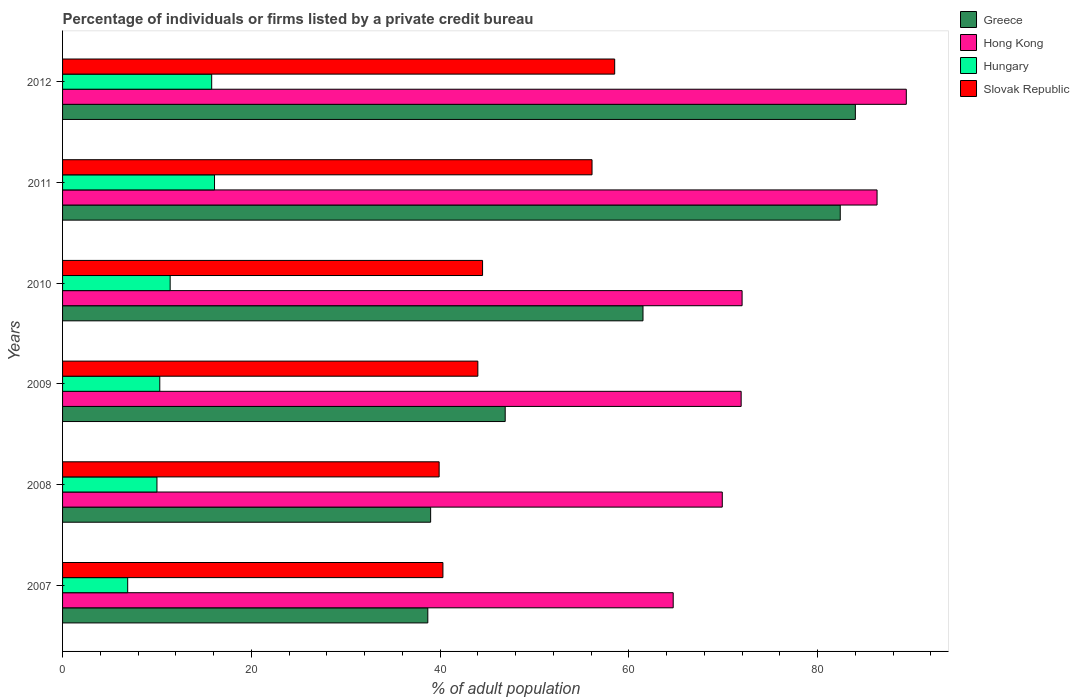How many different coloured bars are there?
Ensure brevity in your answer.  4. Are the number of bars per tick equal to the number of legend labels?
Ensure brevity in your answer.  Yes. Are the number of bars on each tick of the Y-axis equal?
Offer a terse response. Yes. How many bars are there on the 3rd tick from the bottom?
Make the answer very short. 4. Across all years, what is the maximum percentage of population listed by a private credit bureau in Hungary?
Keep it short and to the point. 16.1. Across all years, what is the minimum percentage of population listed by a private credit bureau in Slovak Republic?
Give a very brief answer. 39.9. In which year was the percentage of population listed by a private credit bureau in Greece minimum?
Give a very brief answer. 2007. What is the total percentage of population listed by a private credit bureau in Slovak Republic in the graph?
Ensure brevity in your answer.  283.3. What is the difference between the percentage of population listed by a private credit bureau in Greece in 2010 and that in 2012?
Provide a short and direct response. -22.5. What is the difference between the percentage of population listed by a private credit bureau in Slovak Republic in 2011 and the percentage of population listed by a private credit bureau in Hungary in 2007?
Your response must be concise. 49.2. What is the average percentage of population listed by a private credit bureau in Greece per year?
Keep it short and to the point. 58.75. What is the ratio of the percentage of population listed by a private credit bureau in Hong Kong in 2007 to that in 2012?
Your answer should be very brief. 0.72. Is the percentage of population listed by a private credit bureau in Hong Kong in 2007 less than that in 2012?
Your answer should be very brief. Yes. What is the difference between the highest and the second highest percentage of population listed by a private credit bureau in Slovak Republic?
Give a very brief answer. 2.4. What is the difference between the highest and the lowest percentage of population listed by a private credit bureau in Slovak Republic?
Provide a succinct answer. 18.6. In how many years, is the percentage of population listed by a private credit bureau in Slovak Republic greater than the average percentage of population listed by a private credit bureau in Slovak Republic taken over all years?
Provide a succinct answer. 2. Is the sum of the percentage of population listed by a private credit bureau in Greece in 2011 and 2012 greater than the maximum percentage of population listed by a private credit bureau in Slovak Republic across all years?
Your answer should be very brief. Yes. Is it the case that in every year, the sum of the percentage of population listed by a private credit bureau in Hong Kong and percentage of population listed by a private credit bureau in Slovak Republic is greater than the sum of percentage of population listed by a private credit bureau in Greece and percentage of population listed by a private credit bureau in Hungary?
Provide a succinct answer. Yes. What does the 1st bar from the top in 2011 represents?
Keep it short and to the point. Slovak Republic. Is it the case that in every year, the sum of the percentage of population listed by a private credit bureau in Hong Kong and percentage of population listed by a private credit bureau in Slovak Republic is greater than the percentage of population listed by a private credit bureau in Greece?
Keep it short and to the point. Yes. Are all the bars in the graph horizontal?
Ensure brevity in your answer.  Yes. Are the values on the major ticks of X-axis written in scientific E-notation?
Your answer should be compact. No. Does the graph contain grids?
Give a very brief answer. No. Where does the legend appear in the graph?
Your response must be concise. Top right. What is the title of the graph?
Provide a short and direct response. Percentage of individuals or firms listed by a private credit bureau. What is the label or title of the X-axis?
Ensure brevity in your answer.  % of adult population. What is the % of adult population in Greece in 2007?
Make the answer very short. 38.7. What is the % of adult population of Hong Kong in 2007?
Your response must be concise. 64.7. What is the % of adult population in Slovak Republic in 2007?
Provide a short and direct response. 40.3. What is the % of adult population of Greece in 2008?
Keep it short and to the point. 39. What is the % of adult population of Hong Kong in 2008?
Keep it short and to the point. 69.9. What is the % of adult population of Slovak Republic in 2008?
Ensure brevity in your answer.  39.9. What is the % of adult population of Greece in 2009?
Provide a succinct answer. 46.9. What is the % of adult population in Hong Kong in 2009?
Ensure brevity in your answer.  71.9. What is the % of adult population of Hungary in 2009?
Make the answer very short. 10.3. What is the % of adult population of Slovak Republic in 2009?
Make the answer very short. 44. What is the % of adult population of Greece in 2010?
Keep it short and to the point. 61.5. What is the % of adult population of Hong Kong in 2010?
Provide a short and direct response. 72. What is the % of adult population of Slovak Republic in 2010?
Keep it short and to the point. 44.5. What is the % of adult population of Greece in 2011?
Your answer should be compact. 82.4. What is the % of adult population in Hong Kong in 2011?
Your answer should be compact. 86.3. What is the % of adult population of Hungary in 2011?
Provide a succinct answer. 16.1. What is the % of adult population of Slovak Republic in 2011?
Your answer should be very brief. 56.1. What is the % of adult population of Hong Kong in 2012?
Keep it short and to the point. 89.4. What is the % of adult population of Hungary in 2012?
Your answer should be very brief. 15.8. What is the % of adult population in Slovak Republic in 2012?
Your answer should be very brief. 58.5. Across all years, what is the maximum % of adult population in Hong Kong?
Your answer should be very brief. 89.4. Across all years, what is the maximum % of adult population in Slovak Republic?
Your response must be concise. 58.5. Across all years, what is the minimum % of adult population of Greece?
Provide a succinct answer. 38.7. Across all years, what is the minimum % of adult population in Hong Kong?
Offer a very short reply. 64.7. Across all years, what is the minimum % of adult population of Hungary?
Provide a succinct answer. 6.9. Across all years, what is the minimum % of adult population of Slovak Republic?
Ensure brevity in your answer.  39.9. What is the total % of adult population of Greece in the graph?
Provide a short and direct response. 352.5. What is the total % of adult population of Hong Kong in the graph?
Ensure brevity in your answer.  454.2. What is the total % of adult population of Hungary in the graph?
Your answer should be compact. 70.5. What is the total % of adult population in Slovak Republic in the graph?
Offer a very short reply. 283.3. What is the difference between the % of adult population of Greece in 2007 and that in 2008?
Offer a very short reply. -0.3. What is the difference between the % of adult population in Hong Kong in 2007 and that in 2008?
Ensure brevity in your answer.  -5.2. What is the difference between the % of adult population in Greece in 2007 and that in 2009?
Offer a terse response. -8.2. What is the difference between the % of adult population in Hungary in 2007 and that in 2009?
Ensure brevity in your answer.  -3.4. What is the difference between the % of adult population of Slovak Republic in 2007 and that in 2009?
Keep it short and to the point. -3.7. What is the difference between the % of adult population in Greece in 2007 and that in 2010?
Give a very brief answer. -22.8. What is the difference between the % of adult population of Hong Kong in 2007 and that in 2010?
Your answer should be compact. -7.3. What is the difference between the % of adult population of Hungary in 2007 and that in 2010?
Your answer should be compact. -4.5. What is the difference between the % of adult population of Slovak Republic in 2007 and that in 2010?
Your answer should be very brief. -4.2. What is the difference between the % of adult population of Greece in 2007 and that in 2011?
Offer a terse response. -43.7. What is the difference between the % of adult population in Hong Kong in 2007 and that in 2011?
Give a very brief answer. -21.6. What is the difference between the % of adult population in Hungary in 2007 and that in 2011?
Give a very brief answer. -9.2. What is the difference between the % of adult population of Slovak Republic in 2007 and that in 2011?
Offer a terse response. -15.8. What is the difference between the % of adult population in Greece in 2007 and that in 2012?
Ensure brevity in your answer.  -45.3. What is the difference between the % of adult population of Hong Kong in 2007 and that in 2012?
Ensure brevity in your answer.  -24.7. What is the difference between the % of adult population of Slovak Republic in 2007 and that in 2012?
Offer a terse response. -18.2. What is the difference between the % of adult population in Hong Kong in 2008 and that in 2009?
Your answer should be very brief. -2. What is the difference between the % of adult population of Hungary in 2008 and that in 2009?
Keep it short and to the point. -0.3. What is the difference between the % of adult population of Greece in 2008 and that in 2010?
Offer a terse response. -22.5. What is the difference between the % of adult population of Hungary in 2008 and that in 2010?
Ensure brevity in your answer.  -1.4. What is the difference between the % of adult population in Slovak Republic in 2008 and that in 2010?
Offer a very short reply. -4.6. What is the difference between the % of adult population in Greece in 2008 and that in 2011?
Provide a short and direct response. -43.4. What is the difference between the % of adult population in Hong Kong in 2008 and that in 2011?
Ensure brevity in your answer.  -16.4. What is the difference between the % of adult population in Slovak Republic in 2008 and that in 2011?
Provide a succinct answer. -16.2. What is the difference between the % of adult population of Greece in 2008 and that in 2012?
Offer a very short reply. -45. What is the difference between the % of adult population of Hong Kong in 2008 and that in 2012?
Your response must be concise. -19.5. What is the difference between the % of adult population in Slovak Republic in 2008 and that in 2012?
Offer a very short reply. -18.6. What is the difference between the % of adult population in Greece in 2009 and that in 2010?
Offer a very short reply. -14.6. What is the difference between the % of adult population in Slovak Republic in 2009 and that in 2010?
Keep it short and to the point. -0.5. What is the difference between the % of adult population in Greece in 2009 and that in 2011?
Provide a short and direct response. -35.5. What is the difference between the % of adult population in Hong Kong in 2009 and that in 2011?
Your answer should be compact. -14.4. What is the difference between the % of adult population of Hungary in 2009 and that in 2011?
Offer a very short reply. -5.8. What is the difference between the % of adult population of Greece in 2009 and that in 2012?
Your answer should be very brief. -37.1. What is the difference between the % of adult population in Hong Kong in 2009 and that in 2012?
Your answer should be very brief. -17.5. What is the difference between the % of adult population of Hungary in 2009 and that in 2012?
Your answer should be compact. -5.5. What is the difference between the % of adult population in Slovak Republic in 2009 and that in 2012?
Your response must be concise. -14.5. What is the difference between the % of adult population in Greece in 2010 and that in 2011?
Offer a terse response. -20.9. What is the difference between the % of adult population in Hong Kong in 2010 and that in 2011?
Ensure brevity in your answer.  -14.3. What is the difference between the % of adult population in Hungary in 2010 and that in 2011?
Make the answer very short. -4.7. What is the difference between the % of adult population of Slovak Republic in 2010 and that in 2011?
Your answer should be very brief. -11.6. What is the difference between the % of adult population of Greece in 2010 and that in 2012?
Provide a succinct answer. -22.5. What is the difference between the % of adult population in Hong Kong in 2010 and that in 2012?
Provide a short and direct response. -17.4. What is the difference between the % of adult population in Hungary in 2010 and that in 2012?
Keep it short and to the point. -4.4. What is the difference between the % of adult population of Slovak Republic in 2010 and that in 2012?
Your answer should be compact. -14. What is the difference between the % of adult population in Greece in 2011 and that in 2012?
Your answer should be very brief. -1.6. What is the difference between the % of adult population of Hong Kong in 2011 and that in 2012?
Offer a terse response. -3.1. What is the difference between the % of adult population in Hungary in 2011 and that in 2012?
Ensure brevity in your answer.  0.3. What is the difference between the % of adult population in Greece in 2007 and the % of adult population in Hong Kong in 2008?
Ensure brevity in your answer.  -31.2. What is the difference between the % of adult population in Greece in 2007 and the % of adult population in Hungary in 2008?
Give a very brief answer. 28.7. What is the difference between the % of adult population of Hong Kong in 2007 and the % of adult population of Hungary in 2008?
Provide a short and direct response. 54.7. What is the difference between the % of adult population of Hong Kong in 2007 and the % of adult population of Slovak Republic in 2008?
Your answer should be very brief. 24.8. What is the difference between the % of adult population of Hungary in 2007 and the % of adult population of Slovak Republic in 2008?
Make the answer very short. -33. What is the difference between the % of adult population of Greece in 2007 and the % of adult population of Hong Kong in 2009?
Your answer should be very brief. -33.2. What is the difference between the % of adult population in Greece in 2007 and the % of adult population in Hungary in 2009?
Offer a terse response. 28.4. What is the difference between the % of adult population of Hong Kong in 2007 and the % of adult population of Hungary in 2009?
Keep it short and to the point. 54.4. What is the difference between the % of adult population in Hong Kong in 2007 and the % of adult population in Slovak Republic in 2009?
Provide a succinct answer. 20.7. What is the difference between the % of adult population in Hungary in 2007 and the % of adult population in Slovak Republic in 2009?
Your response must be concise. -37.1. What is the difference between the % of adult population in Greece in 2007 and the % of adult population in Hong Kong in 2010?
Give a very brief answer. -33.3. What is the difference between the % of adult population of Greece in 2007 and the % of adult population of Hungary in 2010?
Provide a succinct answer. 27.3. What is the difference between the % of adult population of Hong Kong in 2007 and the % of adult population of Hungary in 2010?
Offer a very short reply. 53.3. What is the difference between the % of adult population of Hong Kong in 2007 and the % of adult population of Slovak Republic in 2010?
Offer a very short reply. 20.2. What is the difference between the % of adult population of Hungary in 2007 and the % of adult population of Slovak Republic in 2010?
Your answer should be compact. -37.6. What is the difference between the % of adult population in Greece in 2007 and the % of adult population in Hong Kong in 2011?
Keep it short and to the point. -47.6. What is the difference between the % of adult population of Greece in 2007 and the % of adult population of Hungary in 2011?
Provide a short and direct response. 22.6. What is the difference between the % of adult population in Greece in 2007 and the % of adult population in Slovak Republic in 2011?
Offer a very short reply. -17.4. What is the difference between the % of adult population in Hong Kong in 2007 and the % of adult population in Hungary in 2011?
Provide a short and direct response. 48.6. What is the difference between the % of adult population of Hong Kong in 2007 and the % of adult population of Slovak Republic in 2011?
Give a very brief answer. 8.6. What is the difference between the % of adult population in Hungary in 2007 and the % of adult population in Slovak Republic in 2011?
Ensure brevity in your answer.  -49.2. What is the difference between the % of adult population in Greece in 2007 and the % of adult population in Hong Kong in 2012?
Offer a very short reply. -50.7. What is the difference between the % of adult population of Greece in 2007 and the % of adult population of Hungary in 2012?
Provide a short and direct response. 22.9. What is the difference between the % of adult population in Greece in 2007 and the % of adult population in Slovak Republic in 2012?
Keep it short and to the point. -19.8. What is the difference between the % of adult population of Hong Kong in 2007 and the % of adult population of Hungary in 2012?
Provide a succinct answer. 48.9. What is the difference between the % of adult population of Hungary in 2007 and the % of adult population of Slovak Republic in 2012?
Your answer should be very brief. -51.6. What is the difference between the % of adult population in Greece in 2008 and the % of adult population in Hong Kong in 2009?
Keep it short and to the point. -32.9. What is the difference between the % of adult population of Greece in 2008 and the % of adult population of Hungary in 2009?
Give a very brief answer. 28.7. What is the difference between the % of adult population of Greece in 2008 and the % of adult population of Slovak Republic in 2009?
Provide a succinct answer. -5. What is the difference between the % of adult population in Hong Kong in 2008 and the % of adult population in Hungary in 2009?
Provide a succinct answer. 59.6. What is the difference between the % of adult population of Hong Kong in 2008 and the % of adult population of Slovak Republic in 2009?
Your response must be concise. 25.9. What is the difference between the % of adult population of Hungary in 2008 and the % of adult population of Slovak Republic in 2009?
Keep it short and to the point. -34. What is the difference between the % of adult population in Greece in 2008 and the % of adult population in Hong Kong in 2010?
Your answer should be very brief. -33. What is the difference between the % of adult population in Greece in 2008 and the % of adult population in Hungary in 2010?
Provide a short and direct response. 27.6. What is the difference between the % of adult population in Greece in 2008 and the % of adult population in Slovak Republic in 2010?
Provide a succinct answer. -5.5. What is the difference between the % of adult population of Hong Kong in 2008 and the % of adult population of Hungary in 2010?
Provide a short and direct response. 58.5. What is the difference between the % of adult population in Hong Kong in 2008 and the % of adult population in Slovak Republic in 2010?
Offer a very short reply. 25.4. What is the difference between the % of adult population of Hungary in 2008 and the % of adult population of Slovak Republic in 2010?
Provide a short and direct response. -34.5. What is the difference between the % of adult population in Greece in 2008 and the % of adult population in Hong Kong in 2011?
Your answer should be compact. -47.3. What is the difference between the % of adult population of Greece in 2008 and the % of adult population of Hungary in 2011?
Make the answer very short. 22.9. What is the difference between the % of adult population of Greece in 2008 and the % of adult population of Slovak Republic in 2011?
Give a very brief answer. -17.1. What is the difference between the % of adult population of Hong Kong in 2008 and the % of adult population of Hungary in 2011?
Provide a succinct answer. 53.8. What is the difference between the % of adult population in Hong Kong in 2008 and the % of adult population in Slovak Republic in 2011?
Give a very brief answer. 13.8. What is the difference between the % of adult population in Hungary in 2008 and the % of adult population in Slovak Republic in 2011?
Your response must be concise. -46.1. What is the difference between the % of adult population in Greece in 2008 and the % of adult population in Hong Kong in 2012?
Provide a short and direct response. -50.4. What is the difference between the % of adult population in Greece in 2008 and the % of adult population in Hungary in 2012?
Provide a succinct answer. 23.2. What is the difference between the % of adult population of Greece in 2008 and the % of adult population of Slovak Republic in 2012?
Your response must be concise. -19.5. What is the difference between the % of adult population of Hong Kong in 2008 and the % of adult population of Hungary in 2012?
Provide a short and direct response. 54.1. What is the difference between the % of adult population of Hong Kong in 2008 and the % of adult population of Slovak Republic in 2012?
Provide a short and direct response. 11.4. What is the difference between the % of adult population in Hungary in 2008 and the % of adult population in Slovak Republic in 2012?
Offer a terse response. -48.5. What is the difference between the % of adult population of Greece in 2009 and the % of adult population of Hong Kong in 2010?
Keep it short and to the point. -25.1. What is the difference between the % of adult population in Greece in 2009 and the % of adult population in Hungary in 2010?
Make the answer very short. 35.5. What is the difference between the % of adult population in Greece in 2009 and the % of adult population in Slovak Republic in 2010?
Your answer should be compact. 2.4. What is the difference between the % of adult population in Hong Kong in 2009 and the % of adult population in Hungary in 2010?
Offer a terse response. 60.5. What is the difference between the % of adult population of Hong Kong in 2009 and the % of adult population of Slovak Republic in 2010?
Provide a short and direct response. 27.4. What is the difference between the % of adult population in Hungary in 2009 and the % of adult population in Slovak Republic in 2010?
Keep it short and to the point. -34.2. What is the difference between the % of adult population of Greece in 2009 and the % of adult population of Hong Kong in 2011?
Your response must be concise. -39.4. What is the difference between the % of adult population of Greece in 2009 and the % of adult population of Hungary in 2011?
Provide a short and direct response. 30.8. What is the difference between the % of adult population of Hong Kong in 2009 and the % of adult population of Hungary in 2011?
Provide a succinct answer. 55.8. What is the difference between the % of adult population in Hong Kong in 2009 and the % of adult population in Slovak Republic in 2011?
Provide a succinct answer. 15.8. What is the difference between the % of adult population of Hungary in 2009 and the % of adult population of Slovak Republic in 2011?
Your response must be concise. -45.8. What is the difference between the % of adult population of Greece in 2009 and the % of adult population of Hong Kong in 2012?
Your answer should be very brief. -42.5. What is the difference between the % of adult population in Greece in 2009 and the % of adult population in Hungary in 2012?
Your answer should be compact. 31.1. What is the difference between the % of adult population of Hong Kong in 2009 and the % of adult population of Hungary in 2012?
Give a very brief answer. 56.1. What is the difference between the % of adult population of Hong Kong in 2009 and the % of adult population of Slovak Republic in 2012?
Offer a terse response. 13.4. What is the difference between the % of adult population in Hungary in 2009 and the % of adult population in Slovak Republic in 2012?
Offer a very short reply. -48.2. What is the difference between the % of adult population of Greece in 2010 and the % of adult population of Hong Kong in 2011?
Your response must be concise. -24.8. What is the difference between the % of adult population in Greece in 2010 and the % of adult population in Hungary in 2011?
Provide a short and direct response. 45.4. What is the difference between the % of adult population in Hong Kong in 2010 and the % of adult population in Hungary in 2011?
Your response must be concise. 55.9. What is the difference between the % of adult population in Hungary in 2010 and the % of adult population in Slovak Republic in 2011?
Offer a terse response. -44.7. What is the difference between the % of adult population in Greece in 2010 and the % of adult population in Hong Kong in 2012?
Ensure brevity in your answer.  -27.9. What is the difference between the % of adult population of Greece in 2010 and the % of adult population of Hungary in 2012?
Give a very brief answer. 45.7. What is the difference between the % of adult population of Greece in 2010 and the % of adult population of Slovak Republic in 2012?
Ensure brevity in your answer.  3. What is the difference between the % of adult population in Hong Kong in 2010 and the % of adult population in Hungary in 2012?
Your response must be concise. 56.2. What is the difference between the % of adult population in Hungary in 2010 and the % of adult population in Slovak Republic in 2012?
Keep it short and to the point. -47.1. What is the difference between the % of adult population of Greece in 2011 and the % of adult population of Hungary in 2012?
Keep it short and to the point. 66.6. What is the difference between the % of adult population in Greece in 2011 and the % of adult population in Slovak Republic in 2012?
Your answer should be compact. 23.9. What is the difference between the % of adult population in Hong Kong in 2011 and the % of adult population in Hungary in 2012?
Your answer should be very brief. 70.5. What is the difference between the % of adult population in Hong Kong in 2011 and the % of adult population in Slovak Republic in 2012?
Provide a succinct answer. 27.8. What is the difference between the % of adult population of Hungary in 2011 and the % of adult population of Slovak Republic in 2012?
Give a very brief answer. -42.4. What is the average % of adult population in Greece per year?
Your answer should be very brief. 58.75. What is the average % of adult population in Hong Kong per year?
Offer a very short reply. 75.7. What is the average % of adult population in Hungary per year?
Your answer should be very brief. 11.75. What is the average % of adult population of Slovak Republic per year?
Offer a terse response. 47.22. In the year 2007, what is the difference between the % of adult population of Greece and % of adult population of Hong Kong?
Your response must be concise. -26. In the year 2007, what is the difference between the % of adult population of Greece and % of adult population of Hungary?
Provide a succinct answer. 31.8. In the year 2007, what is the difference between the % of adult population of Greece and % of adult population of Slovak Republic?
Provide a short and direct response. -1.6. In the year 2007, what is the difference between the % of adult population of Hong Kong and % of adult population of Hungary?
Ensure brevity in your answer.  57.8. In the year 2007, what is the difference between the % of adult population of Hong Kong and % of adult population of Slovak Republic?
Your answer should be very brief. 24.4. In the year 2007, what is the difference between the % of adult population in Hungary and % of adult population in Slovak Republic?
Your answer should be very brief. -33.4. In the year 2008, what is the difference between the % of adult population of Greece and % of adult population of Hong Kong?
Provide a succinct answer. -30.9. In the year 2008, what is the difference between the % of adult population in Greece and % of adult population in Slovak Republic?
Your answer should be compact. -0.9. In the year 2008, what is the difference between the % of adult population in Hong Kong and % of adult population in Hungary?
Keep it short and to the point. 59.9. In the year 2008, what is the difference between the % of adult population of Hungary and % of adult population of Slovak Republic?
Give a very brief answer. -29.9. In the year 2009, what is the difference between the % of adult population in Greece and % of adult population in Hungary?
Provide a short and direct response. 36.6. In the year 2009, what is the difference between the % of adult population of Hong Kong and % of adult population of Hungary?
Your response must be concise. 61.6. In the year 2009, what is the difference between the % of adult population in Hong Kong and % of adult population in Slovak Republic?
Your answer should be compact. 27.9. In the year 2009, what is the difference between the % of adult population in Hungary and % of adult population in Slovak Republic?
Your answer should be compact. -33.7. In the year 2010, what is the difference between the % of adult population in Greece and % of adult population in Hungary?
Offer a very short reply. 50.1. In the year 2010, what is the difference between the % of adult population in Hong Kong and % of adult population in Hungary?
Provide a short and direct response. 60.6. In the year 2010, what is the difference between the % of adult population in Hungary and % of adult population in Slovak Republic?
Your response must be concise. -33.1. In the year 2011, what is the difference between the % of adult population in Greece and % of adult population in Hungary?
Provide a succinct answer. 66.3. In the year 2011, what is the difference between the % of adult population in Greece and % of adult population in Slovak Republic?
Give a very brief answer. 26.3. In the year 2011, what is the difference between the % of adult population in Hong Kong and % of adult population in Hungary?
Provide a succinct answer. 70.2. In the year 2011, what is the difference between the % of adult population in Hong Kong and % of adult population in Slovak Republic?
Your answer should be very brief. 30.2. In the year 2011, what is the difference between the % of adult population of Hungary and % of adult population of Slovak Republic?
Your answer should be compact. -40. In the year 2012, what is the difference between the % of adult population of Greece and % of adult population of Hungary?
Your response must be concise. 68.2. In the year 2012, what is the difference between the % of adult population in Hong Kong and % of adult population in Hungary?
Keep it short and to the point. 73.6. In the year 2012, what is the difference between the % of adult population of Hong Kong and % of adult population of Slovak Republic?
Give a very brief answer. 30.9. In the year 2012, what is the difference between the % of adult population of Hungary and % of adult population of Slovak Republic?
Your response must be concise. -42.7. What is the ratio of the % of adult population of Greece in 2007 to that in 2008?
Provide a short and direct response. 0.99. What is the ratio of the % of adult population in Hong Kong in 2007 to that in 2008?
Give a very brief answer. 0.93. What is the ratio of the % of adult population in Hungary in 2007 to that in 2008?
Ensure brevity in your answer.  0.69. What is the ratio of the % of adult population of Greece in 2007 to that in 2009?
Your answer should be compact. 0.83. What is the ratio of the % of adult population in Hong Kong in 2007 to that in 2009?
Provide a short and direct response. 0.9. What is the ratio of the % of adult population of Hungary in 2007 to that in 2009?
Keep it short and to the point. 0.67. What is the ratio of the % of adult population of Slovak Republic in 2007 to that in 2009?
Your answer should be compact. 0.92. What is the ratio of the % of adult population of Greece in 2007 to that in 2010?
Your answer should be very brief. 0.63. What is the ratio of the % of adult population in Hong Kong in 2007 to that in 2010?
Make the answer very short. 0.9. What is the ratio of the % of adult population of Hungary in 2007 to that in 2010?
Keep it short and to the point. 0.61. What is the ratio of the % of adult population of Slovak Republic in 2007 to that in 2010?
Keep it short and to the point. 0.91. What is the ratio of the % of adult population in Greece in 2007 to that in 2011?
Offer a terse response. 0.47. What is the ratio of the % of adult population of Hong Kong in 2007 to that in 2011?
Keep it short and to the point. 0.75. What is the ratio of the % of adult population of Hungary in 2007 to that in 2011?
Provide a succinct answer. 0.43. What is the ratio of the % of adult population in Slovak Republic in 2007 to that in 2011?
Give a very brief answer. 0.72. What is the ratio of the % of adult population of Greece in 2007 to that in 2012?
Ensure brevity in your answer.  0.46. What is the ratio of the % of adult population in Hong Kong in 2007 to that in 2012?
Make the answer very short. 0.72. What is the ratio of the % of adult population of Hungary in 2007 to that in 2012?
Your answer should be compact. 0.44. What is the ratio of the % of adult population of Slovak Republic in 2007 to that in 2012?
Your answer should be compact. 0.69. What is the ratio of the % of adult population of Greece in 2008 to that in 2009?
Offer a very short reply. 0.83. What is the ratio of the % of adult population in Hong Kong in 2008 to that in 2009?
Offer a terse response. 0.97. What is the ratio of the % of adult population of Hungary in 2008 to that in 2009?
Your answer should be compact. 0.97. What is the ratio of the % of adult population in Slovak Republic in 2008 to that in 2009?
Your answer should be very brief. 0.91. What is the ratio of the % of adult population in Greece in 2008 to that in 2010?
Provide a succinct answer. 0.63. What is the ratio of the % of adult population in Hong Kong in 2008 to that in 2010?
Make the answer very short. 0.97. What is the ratio of the % of adult population in Hungary in 2008 to that in 2010?
Offer a terse response. 0.88. What is the ratio of the % of adult population in Slovak Republic in 2008 to that in 2010?
Keep it short and to the point. 0.9. What is the ratio of the % of adult population of Greece in 2008 to that in 2011?
Your answer should be very brief. 0.47. What is the ratio of the % of adult population in Hong Kong in 2008 to that in 2011?
Provide a short and direct response. 0.81. What is the ratio of the % of adult population of Hungary in 2008 to that in 2011?
Offer a terse response. 0.62. What is the ratio of the % of adult population of Slovak Republic in 2008 to that in 2011?
Give a very brief answer. 0.71. What is the ratio of the % of adult population in Greece in 2008 to that in 2012?
Your answer should be compact. 0.46. What is the ratio of the % of adult population of Hong Kong in 2008 to that in 2012?
Keep it short and to the point. 0.78. What is the ratio of the % of adult population in Hungary in 2008 to that in 2012?
Give a very brief answer. 0.63. What is the ratio of the % of adult population in Slovak Republic in 2008 to that in 2012?
Give a very brief answer. 0.68. What is the ratio of the % of adult population in Greece in 2009 to that in 2010?
Your response must be concise. 0.76. What is the ratio of the % of adult population of Hungary in 2009 to that in 2010?
Make the answer very short. 0.9. What is the ratio of the % of adult population of Slovak Republic in 2009 to that in 2010?
Keep it short and to the point. 0.99. What is the ratio of the % of adult population in Greece in 2009 to that in 2011?
Provide a short and direct response. 0.57. What is the ratio of the % of adult population in Hong Kong in 2009 to that in 2011?
Make the answer very short. 0.83. What is the ratio of the % of adult population of Hungary in 2009 to that in 2011?
Ensure brevity in your answer.  0.64. What is the ratio of the % of adult population of Slovak Republic in 2009 to that in 2011?
Offer a very short reply. 0.78. What is the ratio of the % of adult population of Greece in 2009 to that in 2012?
Offer a very short reply. 0.56. What is the ratio of the % of adult population in Hong Kong in 2009 to that in 2012?
Make the answer very short. 0.8. What is the ratio of the % of adult population of Hungary in 2009 to that in 2012?
Your response must be concise. 0.65. What is the ratio of the % of adult population of Slovak Republic in 2009 to that in 2012?
Make the answer very short. 0.75. What is the ratio of the % of adult population of Greece in 2010 to that in 2011?
Your answer should be very brief. 0.75. What is the ratio of the % of adult population in Hong Kong in 2010 to that in 2011?
Provide a succinct answer. 0.83. What is the ratio of the % of adult population of Hungary in 2010 to that in 2011?
Your answer should be very brief. 0.71. What is the ratio of the % of adult population in Slovak Republic in 2010 to that in 2011?
Make the answer very short. 0.79. What is the ratio of the % of adult population in Greece in 2010 to that in 2012?
Ensure brevity in your answer.  0.73. What is the ratio of the % of adult population of Hong Kong in 2010 to that in 2012?
Your answer should be compact. 0.81. What is the ratio of the % of adult population in Hungary in 2010 to that in 2012?
Provide a succinct answer. 0.72. What is the ratio of the % of adult population of Slovak Republic in 2010 to that in 2012?
Your answer should be very brief. 0.76. What is the ratio of the % of adult population in Hong Kong in 2011 to that in 2012?
Make the answer very short. 0.97. What is the ratio of the % of adult population in Hungary in 2011 to that in 2012?
Make the answer very short. 1.02. What is the ratio of the % of adult population of Slovak Republic in 2011 to that in 2012?
Provide a short and direct response. 0.96. What is the difference between the highest and the second highest % of adult population of Greece?
Give a very brief answer. 1.6. What is the difference between the highest and the second highest % of adult population of Hungary?
Give a very brief answer. 0.3. What is the difference between the highest and the second highest % of adult population in Slovak Republic?
Your answer should be compact. 2.4. What is the difference between the highest and the lowest % of adult population of Greece?
Make the answer very short. 45.3. What is the difference between the highest and the lowest % of adult population of Hong Kong?
Your answer should be compact. 24.7. What is the difference between the highest and the lowest % of adult population in Slovak Republic?
Ensure brevity in your answer.  18.6. 